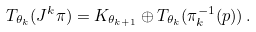Convert formula to latex. <formula><loc_0><loc_0><loc_500><loc_500>T _ { \theta _ { k } } ( J ^ { k } \pi ) = K _ { \theta _ { k + 1 } } \oplus T _ { \theta _ { k } } ( \pi _ { k } ^ { - 1 } ( p ) ) \, .</formula> 